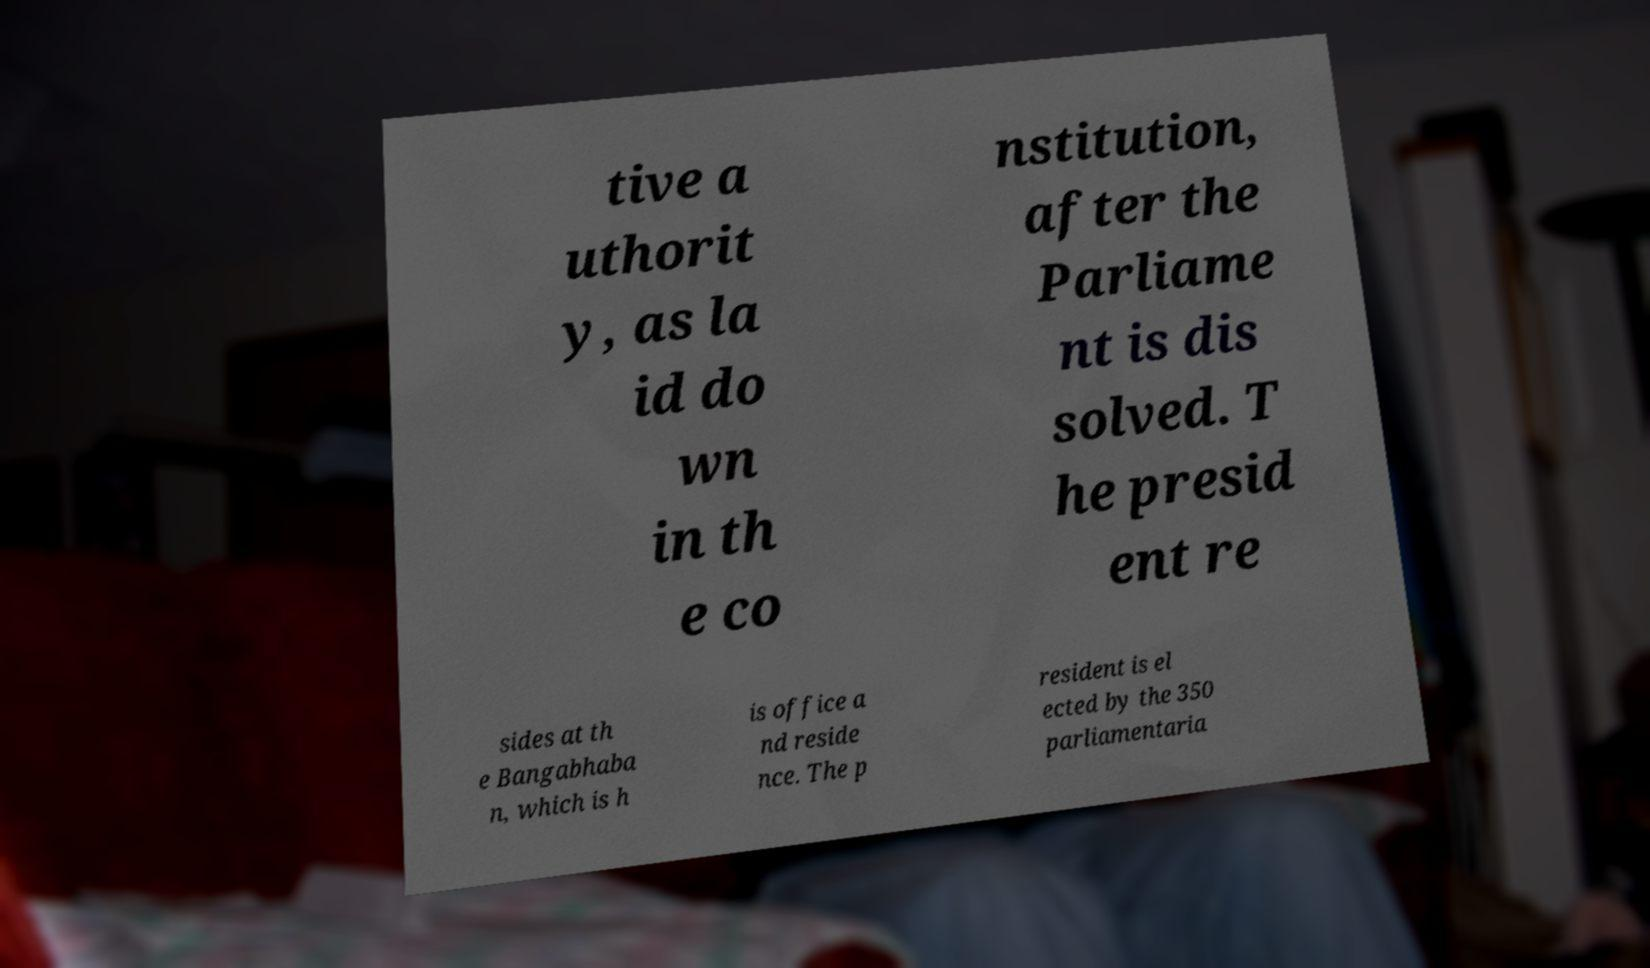For documentation purposes, I need the text within this image transcribed. Could you provide that? tive a uthorit y, as la id do wn in th e co nstitution, after the Parliame nt is dis solved. T he presid ent re sides at th e Bangabhaba n, which is h is office a nd reside nce. The p resident is el ected by the 350 parliamentaria 